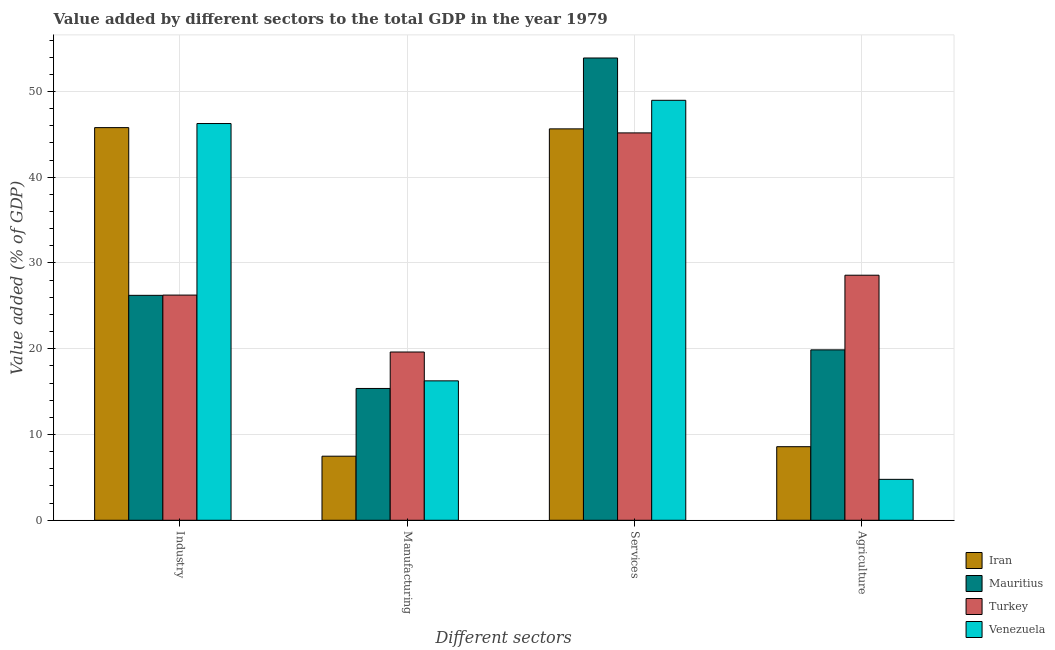How many different coloured bars are there?
Ensure brevity in your answer.  4. How many groups of bars are there?
Provide a succinct answer. 4. Are the number of bars on each tick of the X-axis equal?
Offer a very short reply. Yes. What is the label of the 3rd group of bars from the left?
Make the answer very short. Services. What is the value added by manufacturing sector in Mauritius?
Offer a terse response. 15.37. Across all countries, what is the maximum value added by agricultural sector?
Provide a succinct answer. 28.58. Across all countries, what is the minimum value added by industrial sector?
Ensure brevity in your answer.  26.23. In which country was the value added by manufacturing sector maximum?
Give a very brief answer. Turkey. What is the total value added by manufacturing sector in the graph?
Keep it short and to the point. 58.71. What is the difference between the value added by services sector in Mauritius and that in Turkey?
Ensure brevity in your answer.  8.73. What is the difference between the value added by agricultural sector in Turkey and the value added by manufacturing sector in Venezuela?
Give a very brief answer. 12.32. What is the average value added by industrial sector per country?
Ensure brevity in your answer.  36.13. What is the difference between the value added by agricultural sector and value added by services sector in Mauritius?
Ensure brevity in your answer.  -34.03. What is the ratio of the value added by agricultural sector in Turkey to that in Venezuela?
Your answer should be very brief. 5.99. Is the value added by manufacturing sector in Mauritius less than that in Iran?
Ensure brevity in your answer.  No. Is the difference between the value added by services sector in Turkey and Mauritius greater than the difference between the value added by industrial sector in Turkey and Mauritius?
Make the answer very short. No. What is the difference between the highest and the second highest value added by manufacturing sector?
Offer a very short reply. 3.36. What is the difference between the highest and the lowest value added by industrial sector?
Offer a terse response. 20.03. In how many countries, is the value added by industrial sector greater than the average value added by industrial sector taken over all countries?
Offer a terse response. 2. Is the sum of the value added by manufacturing sector in Mauritius and Turkey greater than the maximum value added by industrial sector across all countries?
Your response must be concise. No. What does the 3rd bar from the right in Agriculture represents?
Keep it short and to the point. Mauritius. Where does the legend appear in the graph?
Your response must be concise. Bottom right. What is the title of the graph?
Your answer should be very brief. Value added by different sectors to the total GDP in the year 1979. Does "Algeria" appear as one of the legend labels in the graph?
Your answer should be compact. No. What is the label or title of the X-axis?
Give a very brief answer. Different sectors. What is the label or title of the Y-axis?
Offer a very short reply. Value added (% of GDP). What is the Value added (% of GDP) in Iran in Industry?
Give a very brief answer. 45.78. What is the Value added (% of GDP) of Mauritius in Industry?
Your answer should be very brief. 26.23. What is the Value added (% of GDP) in Turkey in Industry?
Ensure brevity in your answer.  26.26. What is the Value added (% of GDP) of Venezuela in Industry?
Provide a short and direct response. 46.26. What is the Value added (% of GDP) in Iran in Manufacturing?
Provide a short and direct response. 7.47. What is the Value added (% of GDP) of Mauritius in Manufacturing?
Ensure brevity in your answer.  15.37. What is the Value added (% of GDP) in Turkey in Manufacturing?
Offer a very short reply. 19.62. What is the Value added (% of GDP) of Venezuela in Manufacturing?
Provide a succinct answer. 16.26. What is the Value added (% of GDP) of Iran in Services?
Give a very brief answer. 45.64. What is the Value added (% of GDP) in Mauritius in Services?
Offer a terse response. 53.9. What is the Value added (% of GDP) of Turkey in Services?
Your response must be concise. 45.17. What is the Value added (% of GDP) of Venezuela in Services?
Your response must be concise. 48.97. What is the Value added (% of GDP) of Iran in Agriculture?
Provide a short and direct response. 8.58. What is the Value added (% of GDP) of Mauritius in Agriculture?
Offer a very short reply. 19.87. What is the Value added (% of GDP) in Turkey in Agriculture?
Make the answer very short. 28.58. What is the Value added (% of GDP) in Venezuela in Agriculture?
Give a very brief answer. 4.77. Across all Different sectors, what is the maximum Value added (% of GDP) in Iran?
Offer a very short reply. 45.78. Across all Different sectors, what is the maximum Value added (% of GDP) of Mauritius?
Provide a succinct answer. 53.9. Across all Different sectors, what is the maximum Value added (% of GDP) in Turkey?
Give a very brief answer. 45.17. Across all Different sectors, what is the maximum Value added (% of GDP) in Venezuela?
Ensure brevity in your answer.  48.97. Across all Different sectors, what is the minimum Value added (% of GDP) of Iran?
Keep it short and to the point. 7.47. Across all Different sectors, what is the minimum Value added (% of GDP) of Mauritius?
Give a very brief answer. 15.37. Across all Different sectors, what is the minimum Value added (% of GDP) in Turkey?
Your answer should be very brief. 19.62. Across all Different sectors, what is the minimum Value added (% of GDP) of Venezuela?
Make the answer very short. 4.77. What is the total Value added (% of GDP) of Iran in the graph?
Keep it short and to the point. 107.47. What is the total Value added (% of GDP) of Mauritius in the graph?
Make the answer very short. 115.37. What is the total Value added (% of GDP) of Turkey in the graph?
Provide a short and direct response. 119.62. What is the total Value added (% of GDP) of Venezuela in the graph?
Ensure brevity in your answer.  116.26. What is the difference between the Value added (% of GDP) of Iran in Industry and that in Manufacturing?
Offer a very short reply. 38.31. What is the difference between the Value added (% of GDP) of Mauritius in Industry and that in Manufacturing?
Your answer should be compact. 10.86. What is the difference between the Value added (% of GDP) in Turkey in Industry and that in Manufacturing?
Provide a succinct answer. 6.64. What is the difference between the Value added (% of GDP) of Venezuela in Industry and that in Manufacturing?
Ensure brevity in your answer.  30. What is the difference between the Value added (% of GDP) in Iran in Industry and that in Services?
Give a very brief answer. 0.15. What is the difference between the Value added (% of GDP) in Mauritius in Industry and that in Services?
Your answer should be very brief. -27.68. What is the difference between the Value added (% of GDP) of Turkey in Industry and that in Services?
Offer a terse response. -18.91. What is the difference between the Value added (% of GDP) in Venezuela in Industry and that in Services?
Provide a short and direct response. -2.71. What is the difference between the Value added (% of GDP) of Iran in Industry and that in Agriculture?
Provide a short and direct response. 37.21. What is the difference between the Value added (% of GDP) of Mauritius in Industry and that in Agriculture?
Offer a very short reply. 6.36. What is the difference between the Value added (% of GDP) of Turkey in Industry and that in Agriculture?
Keep it short and to the point. -2.32. What is the difference between the Value added (% of GDP) of Venezuela in Industry and that in Agriculture?
Offer a terse response. 41.49. What is the difference between the Value added (% of GDP) of Iran in Manufacturing and that in Services?
Provide a short and direct response. -38.17. What is the difference between the Value added (% of GDP) in Mauritius in Manufacturing and that in Services?
Offer a very short reply. -38.53. What is the difference between the Value added (% of GDP) of Turkey in Manufacturing and that in Services?
Offer a very short reply. -25.55. What is the difference between the Value added (% of GDP) of Venezuela in Manufacturing and that in Services?
Your answer should be very brief. -32.71. What is the difference between the Value added (% of GDP) in Iran in Manufacturing and that in Agriculture?
Your answer should be compact. -1.11. What is the difference between the Value added (% of GDP) in Mauritius in Manufacturing and that in Agriculture?
Provide a short and direct response. -4.5. What is the difference between the Value added (% of GDP) in Turkey in Manufacturing and that in Agriculture?
Provide a short and direct response. -8.96. What is the difference between the Value added (% of GDP) in Venezuela in Manufacturing and that in Agriculture?
Offer a very short reply. 11.48. What is the difference between the Value added (% of GDP) of Iran in Services and that in Agriculture?
Offer a very short reply. 37.06. What is the difference between the Value added (% of GDP) in Mauritius in Services and that in Agriculture?
Provide a short and direct response. 34.03. What is the difference between the Value added (% of GDP) in Turkey in Services and that in Agriculture?
Your answer should be very brief. 16.59. What is the difference between the Value added (% of GDP) of Venezuela in Services and that in Agriculture?
Make the answer very short. 44.2. What is the difference between the Value added (% of GDP) in Iran in Industry and the Value added (% of GDP) in Mauritius in Manufacturing?
Your response must be concise. 30.42. What is the difference between the Value added (% of GDP) of Iran in Industry and the Value added (% of GDP) of Turkey in Manufacturing?
Keep it short and to the point. 26.17. What is the difference between the Value added (% of GDP) in Iran in Industry and the Value added (% of GDP) in Venezuela in Manufacturing?
Provide a succinct answer. 29.53. What is the difference between the Value added (% of GDP) of Mauritius in Industry and the Value added (% of GDP) of Turkey in Manufacturing?
Make the answer very short. 6.61. What is the difference between the Value added (% of GDP) of Mauritius in Industry and the Value added (% of GDP) of Venezuela in Manufacturing?
Your response must be concise. 9.97. What is the difference between the Value added (% of GDP) in Turkey in Industry and the Value added (% of GDP) in Venezuela in Manufacturing?
Keep it short and to the point. 10. What is the difference between the Value added (% of GDP) in Iran in Industry and the Value added (% of GDP) in Mauritius in Services?
Ensure brevity in your answer.  -8.12. What is the difference between the Value added (% of GDP) in Iran in Industry and the Value added (% of GDP) in Turkey in Services?
Ensure brevity in your answer.  0.62. What is the difference between the Value added (% of GDP) of Iran in Industry and the Value added (% of GDP) of Venezuela in Services?
Provide a succinct answer. -3.18. What is the difference between the Value added (% of GDP) of Mauritius in Industry and the Value added (% of GDP) of Turkey in Services?
Make the answer very short. -18.94. What is the difference between the Value added (% of GDP) in Mauritius in Industry and the Value added (% of GDP) in Venezuela in Services?
Ensure brevity in your answer.  -22.74. What is the difference between the Value added (% of GDP) of Turkey in Industry and the Value added (% of GDP) of Venezuela in Services?
Make the answer very short. -22.71. What is the difference between the Value added (% of GDP) of Iran in Industry and the Value added (% of GDP) of Mauritius in Agriculture?
Offer a very short reply. 25.91. What is the difference between the Value added (% of GDP) in Iran in Industry and the Value added (% of GDP) in Turkey in Agriculture?
Provide a succinct answer. 17.21. What is the difference between the Value added (% of GDP) in Iran in Industry and the Value added (% of GDP) in Venezuela in Agriculture?
Give a very brief answer. 41.01. What is the difference between the Value added (% of GDP) of Mauritius in Industry and the Value added (% of GDP) of Turkey in Agriculture?
Provide a short and direct response. -2.35. What is the difference between the Value added (% of GDP) in Mauritius in Industry and the Value added (% of GDP) in Venezuela in Agriculture?
Provide a short and direct response. 21.46. What is the difference between the Value added (% of GDP) in Turkey in Industry and the Value added (% of GDP) in Venezuela in Agriculture?
Provide a short and direct response. 21.49. What is the difference between the Value added (% of GDP) of Iran in Manufacturing and the Value added (% of GDP) of Mauritius in Services?
Keep it short and to the point. -46.43. What is the difference between the Value added (% of GDP) of Iran in Manufacturing and the Value added (% of GDP) of Turkey in Services?
Keep it short and to the point. -37.7. What is the difference between the Value added (% of GDP) of Iran in Manufacturing and the Value added (% of GDP) of Venezuela in Services?
Provide a short and direct response. -41.5. What is the difference between the Value added (% of GDP) in Mauritius in Manufacturing and the Value added (% of GDP) in Turkey in Services?
Ensure brevity in your answer.  -29.8. What is the difference between the Value added (% of GDP) in Mauritius in Manufacturing and the Value added (% of GDP) in Venezuela in Services?
Make the answer very short. -33.6. What is the difference between the Value added (% of GDP) in Turkey in Manufacturing and the Value added (% of GDP) in Venezuela in Services?
Provide a short and direct response. -29.35. What is the difference between the Value added (% of GDP) in Iran in Manufacturing and the Value added (% of GDP) in Mauritius in Agriculture?
Offer a very short reply. -12.4. What is the difference between the Value added (% of GDP) of Iran in Manufacturing and the Value added (% of GDP) of Turkey in Agriculture?
Your answer should be very brief. -21.1. What is the difference between the Value added (% of GDP) of Iran in Manufacturing and the Value added (% of GDP) of Venezuela in Agriculture?
Offer a very short reply. 2.7. What is the difference between the Value added (% of GDP) of Mauritius in Manufacturing and the Value added (% of GDP) of Turkey in Agriculture?
Make the answer very short. -13.21. What is the difference between the Value added (% of GDP) in Mauritius in Manufacturing and the Value added (% of GDP) in Venezuela in Agriculture?
Keep it short and to the point. 10.6. What is the difference between the Value added (% of GDP) of Turkey in Manufacturing and the Value added (% of GDP) of Venezuela in Agriculture?
Give a very brief answer. 14.85. What is the difference between the Value added (% of GDP) of Iran in Services and the Value added (% of GDP) of Mauritius in Agriculture?
Your answer should be compact. 25.77. What is the difference between the Value added (% of GDP) of Iran in Services and the Value added (% of GDP) of Turkey in Agriculture?
Provide a short and direct response. 17.06. What is the difference between the Value added (% of GDP) of Iran in Services and the Value added (% of GDP) of Venezuela in Agriculture?
Give a very brief answer. 40.87. What is the difference between the Value added (% of GDP) in Mauritius in Services and the Value added (% of GDP) in Turkey in Agriculture?
Give a very brief answer. 25.33. What is the difference between the Value added (% of GDP) in Mauritius in Services and the Value added (% of GDP) in Venezuela in Agriculture?
Ensure brevity in your answer.  49.13. What is the difference between the Value added (% of GDP) in Turkey in Services and the Value added (% of GDP) in Venezuela in Agriculture?
Provide a short and direct response. 40.4. What is the average Value added (% of GDP) in Iran per Different sectors?
Your answer should be compact. 26.87. What is the average Value added (% of GDP) of Mauritius per Different sectors?
Provide a short and direct response. 28.84. What is the average Value added (% of GDP) of Turkey per Different sectors?
Provide a succinct answer. 29.9. What is the average Value added (% of GDP) in Venezuela per Different sectors?
Keep it short and to the point. 29.06. What is the difference between the Value added (% of GDP) in Iran and Value added (% of GDP) in Mauritius in Industry?
Your response must be concise. 19.56. What is the difference between the Value added (% of GDP) of Iran and Value added (% of GDP) of Turkey in Industry?
Provide a succinct answer. 19.53. What is the difference between the Value added (% of GDP) in Iran and Value added (% of GDP) in Venezuela in Industry?
Offer a terse response. -0.47. What is the difference between the Value added (% of GDP) in Mauritius and Value added (% of GDP) in Turkey in Industry?
Offer a very short reply. -0.03. What is the difference between the Value added (% of GDP) in Mauritius and Value added (% of GDP) in Venezuela in Industry?
Make the answer very short. -20.03. What is the difference between the Value added (% of GDP) of Turkey and Value added (% of GDP) of Venezuela in Industry?
Provide a short and direct response. -20. What is the difference between the Value added (% of GDP) of Iran and Value added (% of GDP) of Mauritius in Manufacturing?
Make the answer very short. -7.9. What is the difference between the Value added (% of GDP) in Iran and Value added (% of GDP) in Turkey in Manufacturing?
Provide a short and direct response. -12.15. What is the difference between the Value added (% of GDP) of Iran and Value added (% of GDP) of Venezuela in Manufacturing?
Your response must be concise. -8.79. What is the difference between the Value added (% of GDP) in Mauritius and Value added (% of GDP) in Turkey in Manufacturing?
Give a very brief answer. -4.25. What is the difference between the Value added (% of GDP) in Mauritius and Value added (% of GDP) in Venezuela in Manufacturing?
Your response must be concise. -0.89. What is the difference between the Value added (% of GDP) in Turkey and Value added (% of GDP) in Venezuela in Manufacturing?
Your answer should be very brief. 3.36. What is the difference between the Value added (% of GDP) of Iran and Value added (% of GDP) of Mauritius in Services?
Offer a very short reply. -8.27. What is the difference between the Value added (% of GDP) in Iran and Value added (% of GDP) in Turkey in Services?
Your answer should be compact. 0.47. What is the difference between the Value added (% of GDP) in Iran and Value added (% of GDP) in Venezuela in Services?
Your response must be concise. -3.33. What is the difference between the Value added (% of GDP) in Mauritius and Value added (% of GDP) in Turkey in Services?
Your answer should be compact. 8.73. What is the difference between the Value added (% of GDP) of Mauritius and Value added (% of GDP) of Venezuela in Services?
Keep it short and to the point. 4.93. What is the difference between the Value added (% of GDP) in Turkey and Value added (% of GDP) in Venezuela in Services?
Keep it short and to the point. -3.8. What is the difference between the Value added (% of GDP) in Iran and Value added (% of GDP) in Mauritius in Agriculture?
Ensure brevity in your answer.  -11.29. What is the difference between the Value added (% of GDP) of Iran and Value added (% of GDP) of Turkey in Agriculture?
Make the answer very short. -20. What is the difference between the Value added (% of GDP) of Iran and Value added (% of GDP) of Venezuela in Agriculture?
Your answer should be very brief. 3.81. What is the difference between the Value added (% of GDP) in Mauritius and Value added (% of GDP) in Turkey in Agriculture?
Provide a short and direct response. -8.71. What is the difference between the Value added (% of GDP) of Mauritius and Value added (% of GDP) of Venezuela in Agriculture?
Ensure brevity in your answer.  15.1. What is the difference between the Value added (% of GDP) of Turkey and Value added (% of GDP) of Venezuela in Agriculture?
Provide a short and direct response. 23.8. What is the ratio of the Value added (% of GDP) in Iran in Industry to that in Manufacturing?
Offer a terse response. 6.13. What is the ratio of the Value added (% of GDP) in Mauritius in Industry to that in Manufacturing?
Offer a terse response. 1.71. What is the ratio of the Value added (% of GDP) in Turkey in Industry to that in Manufacturing?
Your answer should be compact. 1.34. What is the ratio of the Value added (% of GDP) of Venezuela in Industry to that in Manufacturing?
Make the answer very short. 2.85. What is the ratio of the Value added (% of GDP) in Mauritius in Industry to that in Services?
Make the answer very short. 0.49. What is the ratio of the Value added (% of GDP) in Turkey in Industry to that in Services?
Your response must be concise. 0.58. What is the ratio of the Value added (% of GDP) of Venezuela in Industry to that in Services?
Provide a succinct answer. 0.94. What is the ratio of the Value added (% of GDP) in Iran in Industry to that in Agriculture?
Provide a succinct answer. 5.34. What is the ratio of the Value added (% of GDP) in Mauritius in Industry to that in Agriculture?
Offer a terse response. 1.32. What is the ratio of the Value added (% of GDP) in Turkey in Industry to that in Agriculture?
Provide a succinct answer. 0.92. What is the ratio of the Value added (% of GDP) in Venezuela in Industry to that in Agriculture?
Your answer should be compact. 9.69. What is the ratio of the Value added (% of GDP) of Iran in Manufacturing to that in Services?
Offer a very short reply. 0.16. What is the ratio of the Value added (% of GDP) of Mauritius in Manufacturing to that in Services?
Keep it short and to the point. 0.29. What is the ratio of the Value added (% of GDP) of Turkey in Manufacturing to that in Services?
Offer a very short reply. 0.43. What is the ratio of the Value added (% of GDP) in Venezuela in Manufacturing to that in Services?
Your answer should be compact. 0.33. What is the ratio of the Value added (% of GDP) of Iran in Manufacturing to that in Agriculture?
Ensure brevity in your answer.  0.87. What is the ratio of the Value added (% of GDP) in Mauritius in Manufacturing to that in Agriculture?
Ensure brevity in your answer.  0.77. What is the ratio of the Value added (% of GDP) of Turkey in Manufacturing to that in Agriculture?
Ensure brevity in your answer.  0.69. What is the ratio of the Value added (% of GDP) in Venezuela in Manufacturing to that in Agriculture?
Give a very brief answer. 3.41. What is the ratio of the Value added (% of GDP) in Iran in Services to that in Agriculture?
Your answer should be very brief. 5.32. What is the ratio of the Value added (% of GDP) of Mauritius in Services to that in Agriculture?
Provide a succinct answer. 2.71. What is the ratio of the Value added (% of GDP) of Turkey in Services to that in Agriculture?
Give a very brief answer. 1.58. What is the ratio of the Value added (% of GDP) in Venezuela in Services to that in Agriculture?
Your answer should be compact. 10.26. What is the difference between the highest and the second highest Value added (% of GDP) of Iran?
Keep it short and to the point. 0.15. What is the difference between the highest and the second highest Value added (% of GDP) in Mauritius?
Your answer should be compact. 27.68. What is the difference between the highest and the second highest Value added (% of GDP) of Turkey?
Give a very brief answer. 16.59. What is the difference between the highest and the second highest Value added (% of GDP) of Venezuela?
Your answer should be compact. 2.71. What is the difference between the highest and the lowest Value added (% of GDP) of Iran?
Keep it short and to the point. 38.31. What is the difference between the highest and the lowest Value added (% of GDP) of Mauritius?
Keep it short and to the point. 38.53. What is the difference between the highest and the lowest Value added (% of GDP) of Turkey?
Give a very brief answer. 25.55. What is the difference between the highest and the lowest Value added (% of GDP) of Venezuela?
Offer a very short reply. 44.2. 